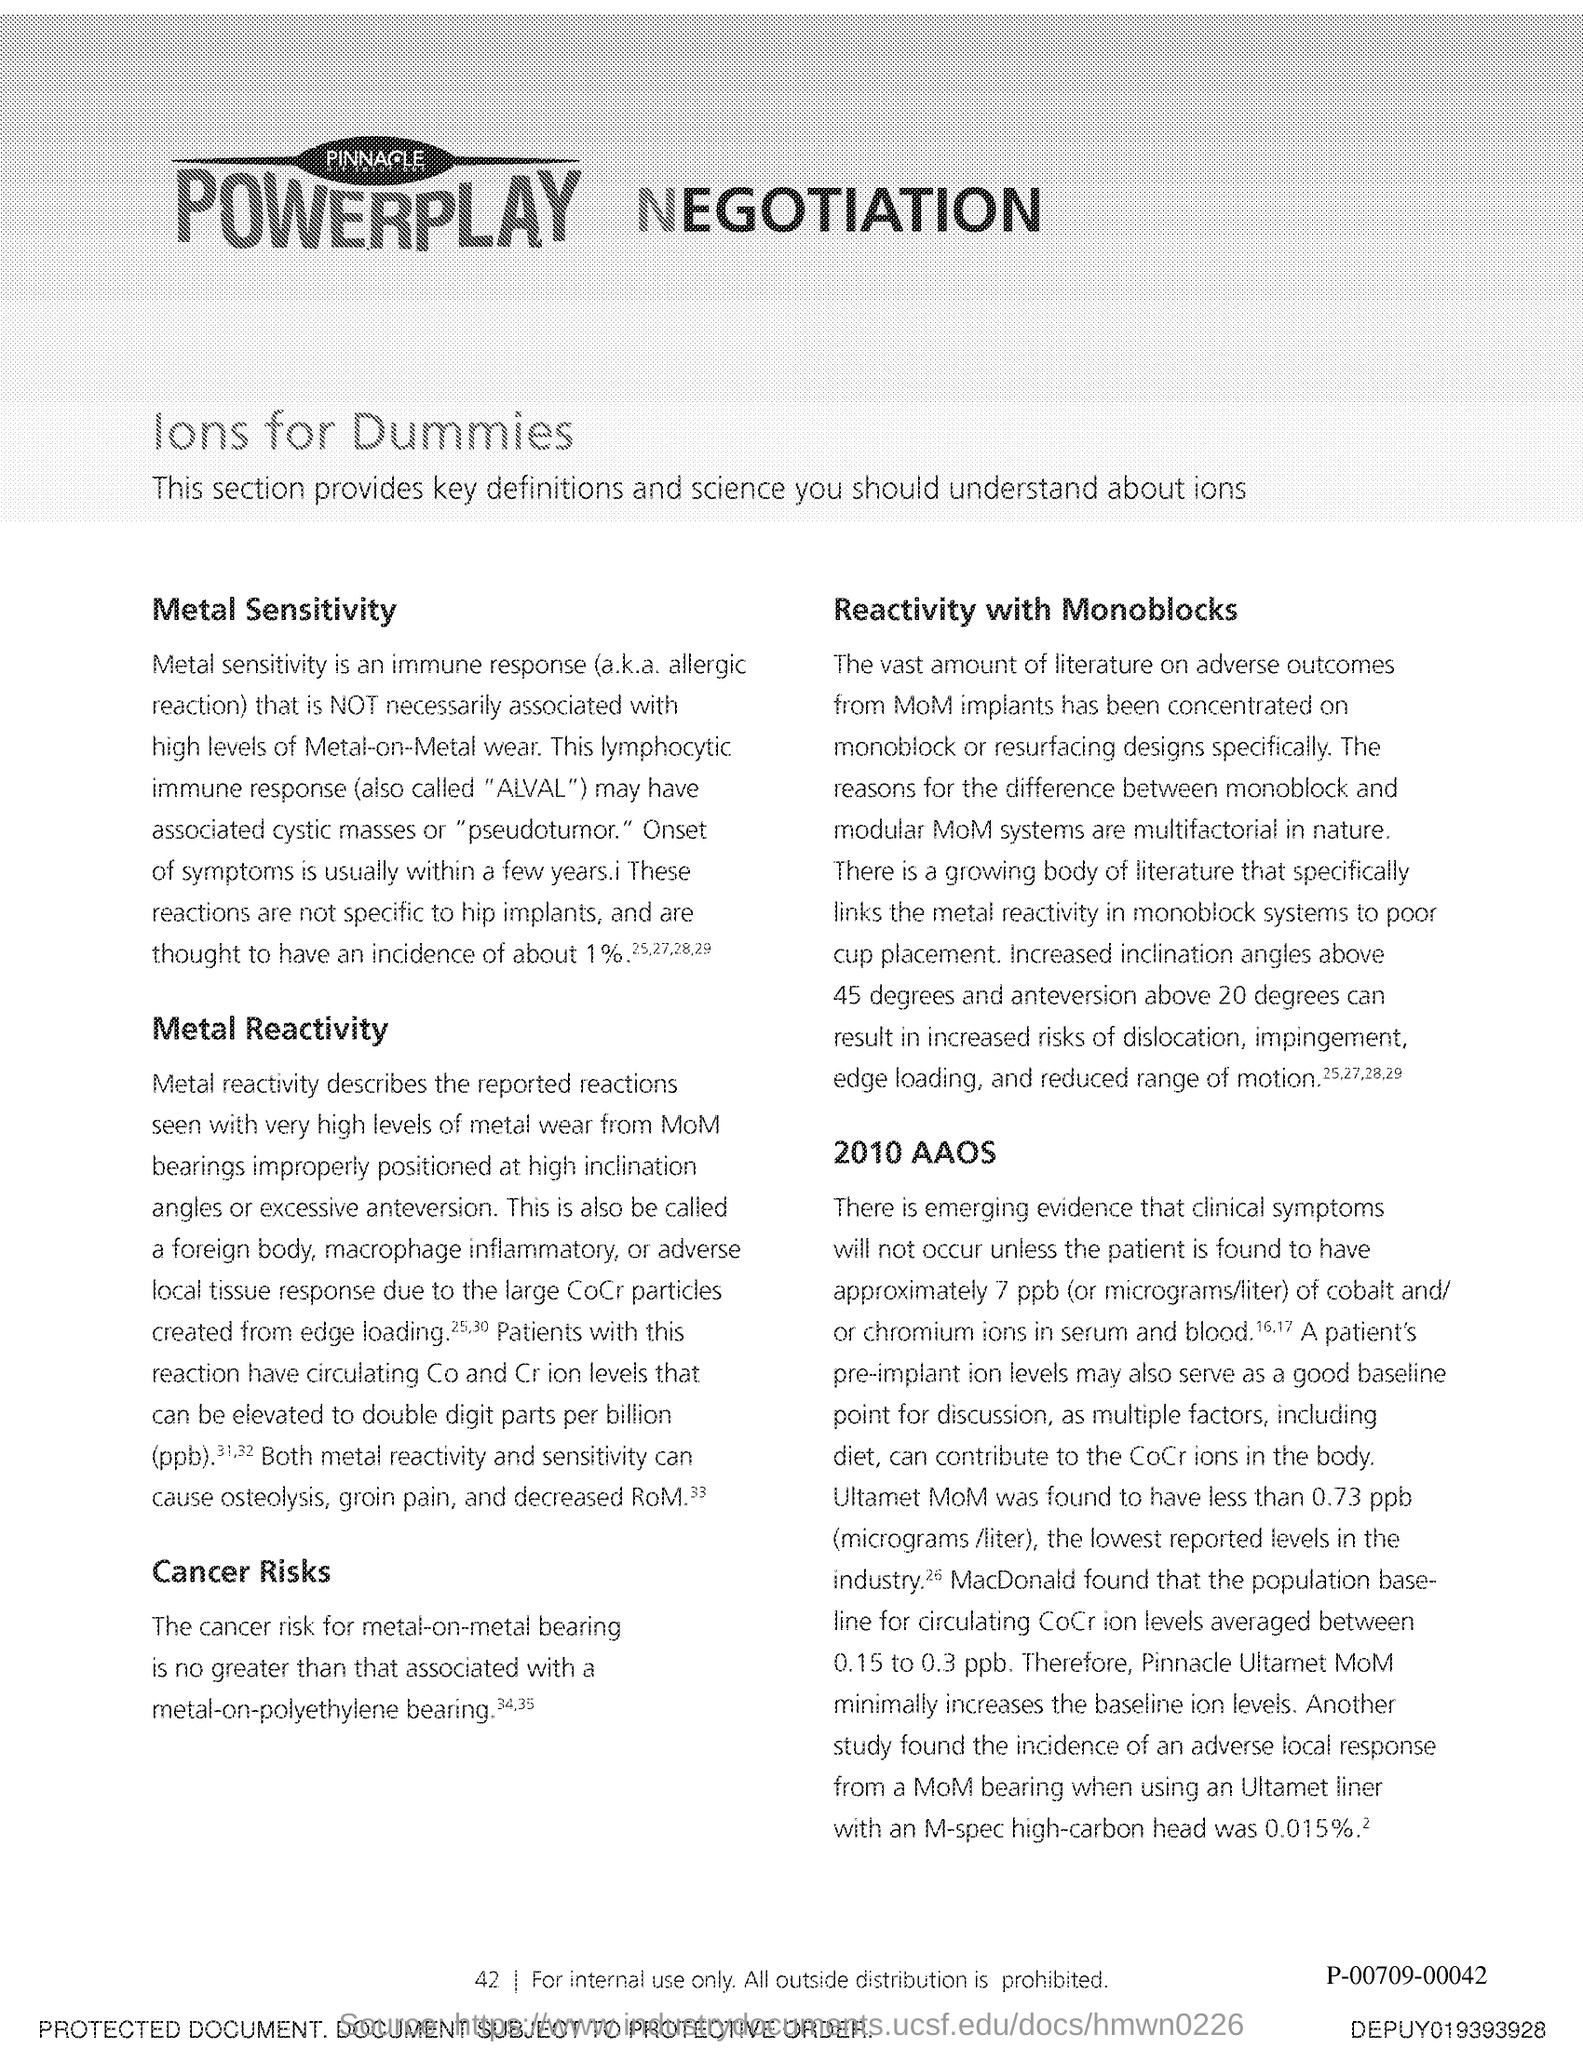Identify some key points in this picture. The page number is 42. 